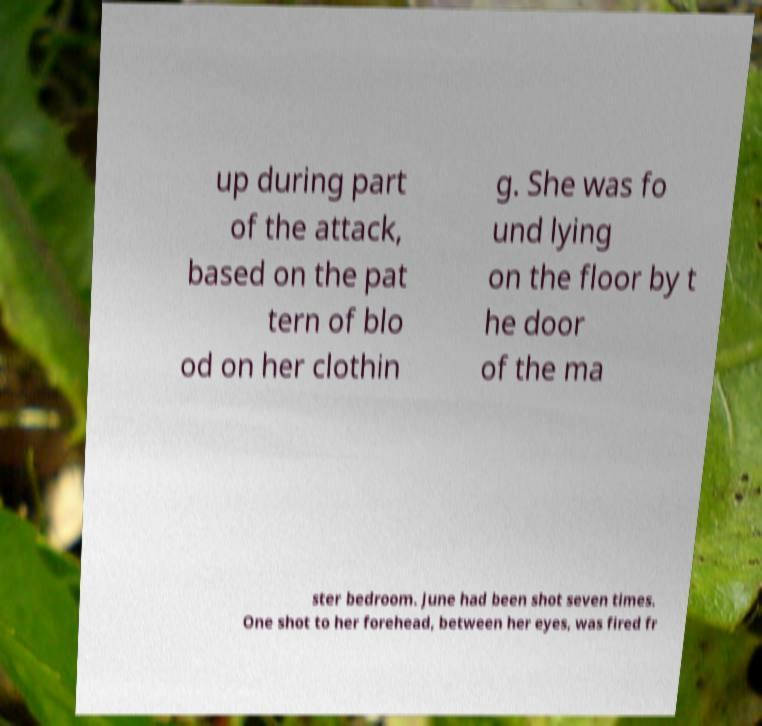For documentation purposes, I need the text within this image transcribed. Could you provide that? up during part of the attack, based on the pat tern of blo od on her clothin g. She was fo und lying on the floor by t he door of the ma ster bedroom. June had been shot seven times. One shot to her forehead, between her eyes, was fired fr 